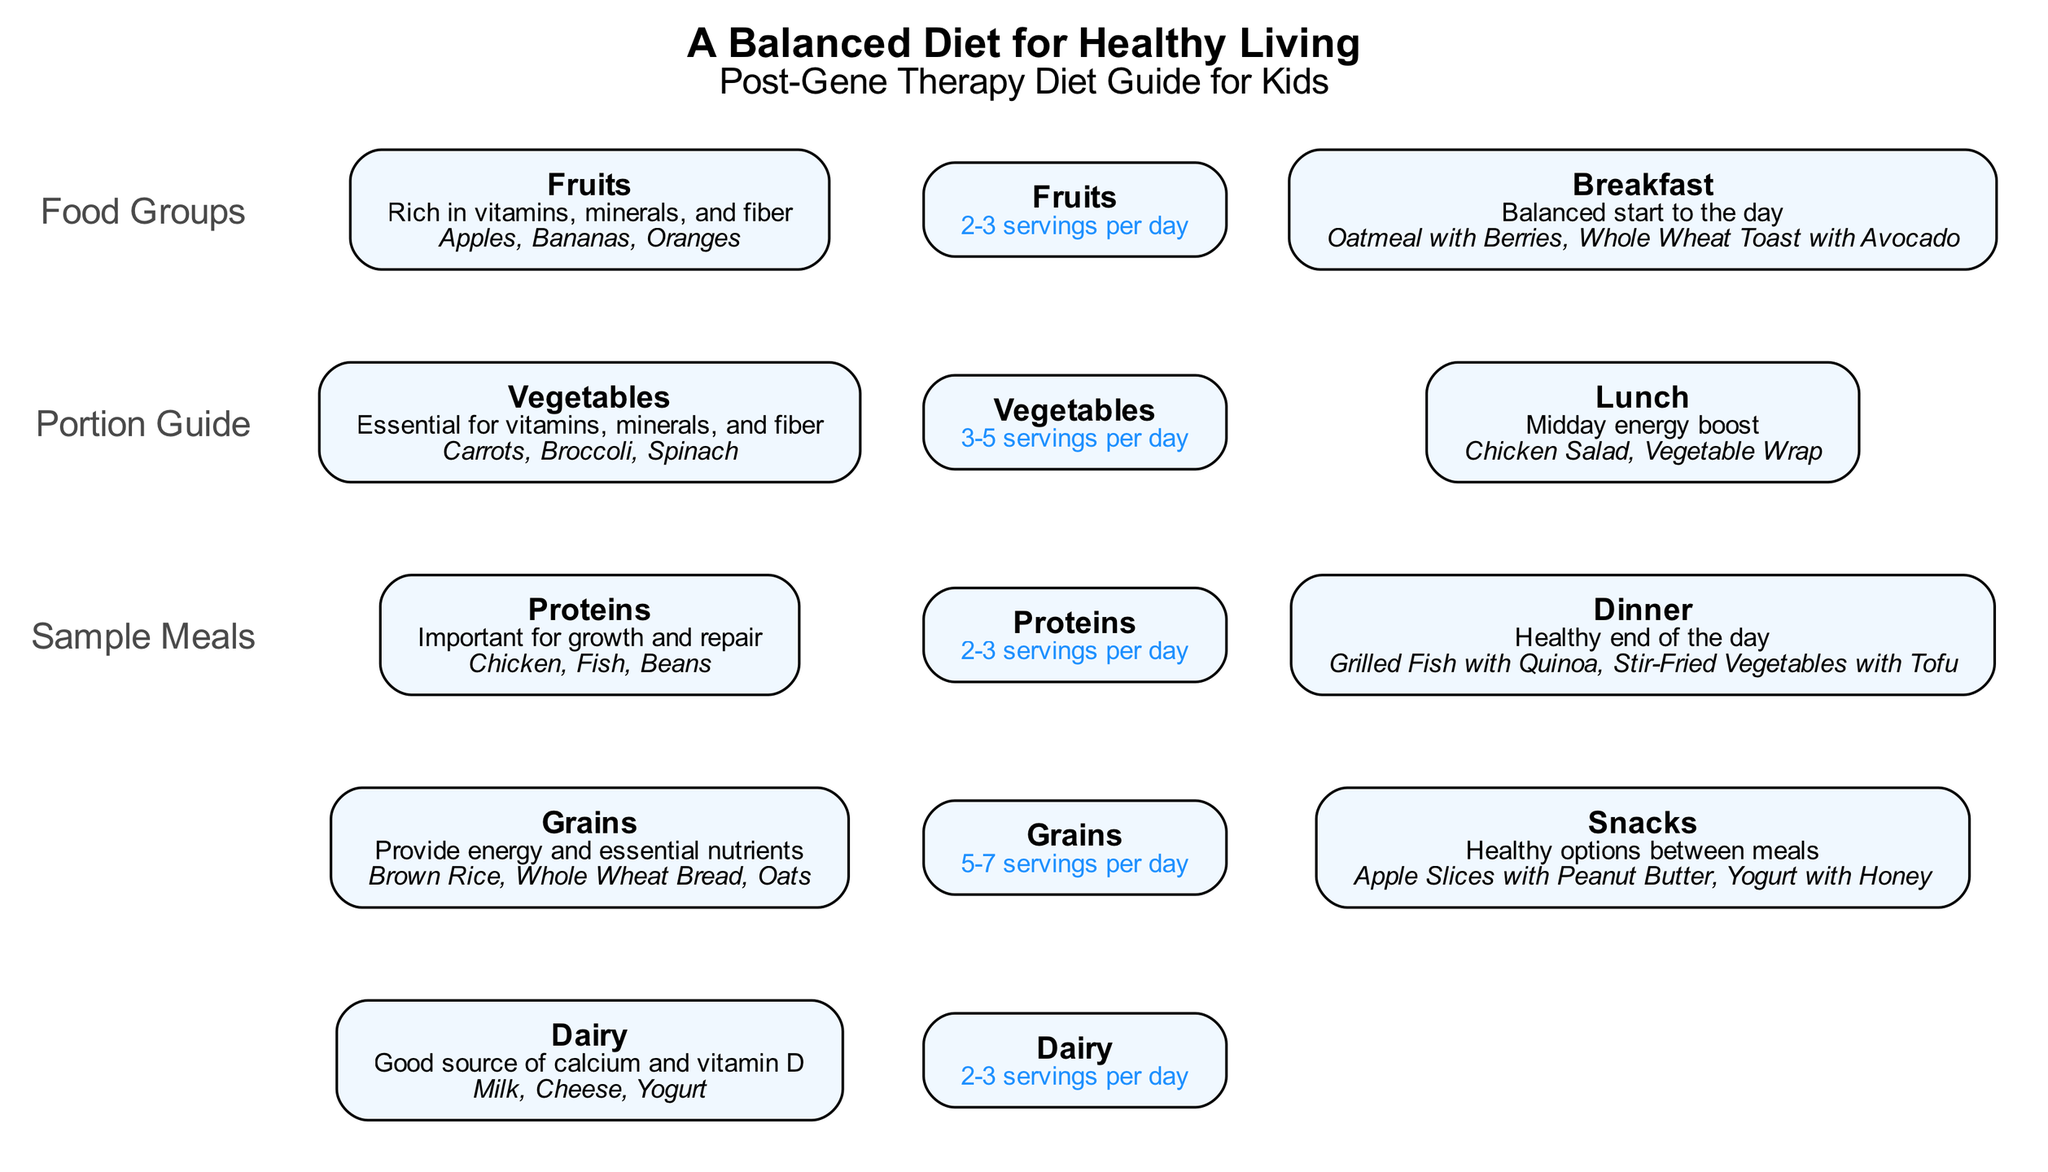What are the two examples of fruits listed? In the "Food Groups" section, I can find the node labeled "Fruits". The details mention that apples and bananas are examples of fruits. These are clearly stated under the examples section of that node.
Answer: Apples, Bananas How many servings of vegetables should one eat per day? In the "Portion Guide" section, I locate the node titled "Vegetables". This node specifies that the recommended portion is 3-5 servings per day. This information allows for a direct response to the question.
Answer: 3-5 servings What is the primary benefit of the protein food group? Referring to the node labeled "Proteins" in the "Food Groups" section, it states that proteins are important for growth and repair. This highlights the fundamental health benefit associated with this food group.
Answer: Growth and repair Which meal is suggested for breakfast? In the "Sample Meals" section, under the node titled "Breakfast", it provides examples such as oatmeal with berries and whole wheat toast with avocado. These examples help identify the suggested breakfast items.
Answer: Oatmeal with Berries, Whole Wheat Toast with Avocado How many food groups are illustrated in the diagram? By reviewing the "Food Groups" section of the diagram, I can count the nodes present. There are five distinct food groups represented: Fruits, Vegetables, Proteins, Grains, and Dairy, indicating the total number of food groups.
Answer: Five 